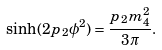Convert formula to latex. <formula><loc_0><loc_0><loc_500><loc_500>\sinh ( 2 p _ { 2 } \phi ^ { 2 } ) = \frac { p _ { 2 } m ^ { 2 } _ { 4 } } { 3 \pi } .</formula> 